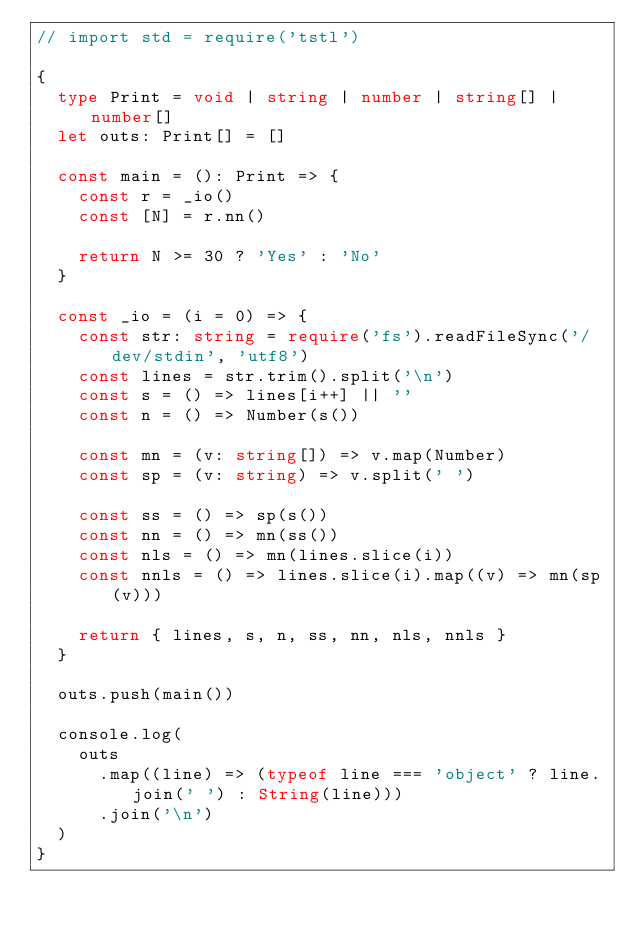Convert code to text. <code><loc_0><loc_0><loc_500><loc_500><_TypeScript_>// import std = require('tstl')

{
  type Print = void | string | number | string[] | number[]
  let outs: Print[] = []

  const main = (): Print => {
    const r = _io()
    const [N] = r.nn()

    return N >= 30 ? 'Yes' : 'No'
  }

  const _io = (i = 0) => {
    const str: string = require('fs').readFileSync('/dev/stdin', 'utf8')
    const lines = str.trim().split('\n')
    const s = () => lines[i++] || ''
    const n = () => Number(s())

    const mn = (v: string[]) => v.map(Number)
    const sp = (v: string) => v.split(' ')

    const ss = () => sp(s())
    const nn = () => mn(ss())
    const nls = () => mn(lines.slice(i))
    const nnls = () => lines.slice(i).map((v) => mn(sp(v)))

    return { lines, s, n, ss, nn, nls, nnls }
  }

  outs.push(main())

  console.log(
    outs
      .map((line) => (typeof line === 'object' ? line.join(' ') : String(line)))
      .join('\n')
  )
}
</code> 